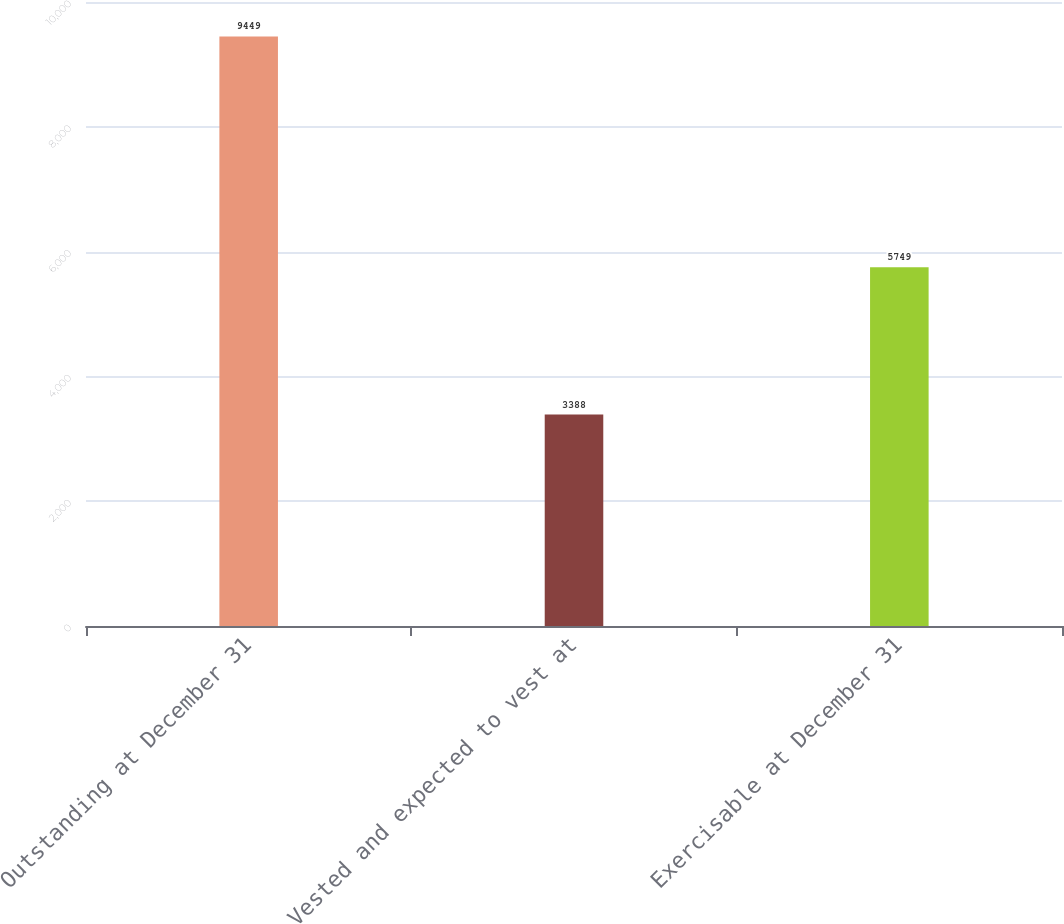Convert chart to OTSL. <chart><loc_0><loc_0><loc_500><loc_500><bar_chart><fcel>Outstanding at December 31<fcel>Vested and expected to vest at<fcel>Exercisable at December 31<nl><fcel>9449<fcel>3388<fcel>5749<nl></chart> 